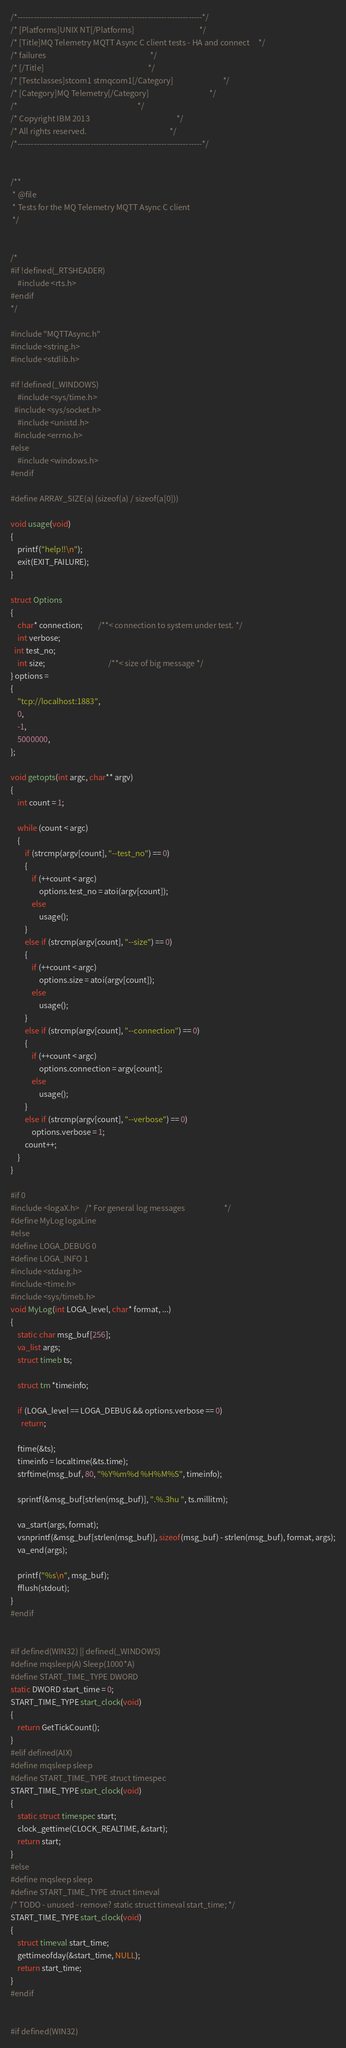Convert code to text. <code><loc_0><loc_0><loc_500><loc_500><_C_>/*--------------------------------------------------------------------*/
/* [Platforms]UNIX NT[/Platforms]                                     */
/* [Title]MQ Telemetry MQTT Async C client tests - HA and connect     */
/* failures                                                           */
/* [/Title]                                                           */
/* [Testclasses]stcom1 stmqcom1[/Category]                            */
/* [Category]MQ Telemetry[/Category]                                  */
/*                                                                    */
/* Copyright IBM 2013                                                 */
/* All rights reserved.                                               */
/*--------------------------------------------------------------------*/


/**
 * @file
 * Tests for the MQ Telemetry MQTT Async C client
 */


/*
#if !defined(_RTSHEADER)
	#include <rts.h>
#endif
*/

#include "MQTTAsync.h"
#include <string.h>
#include <stdlib.h>

#if !defined(_WINDOWS)
	#include <sys/time.h>
  #include <sys/socket.h>
	#include <unistd.h>
  #include <errno.h>
#else
	#include <windows.h>
#endif

#define ARRAY_SIZE(a) (sizeof(a) / sizeof(a[0]))

void usage(void)
{
	printf("help!!\n");
	exit(EXIT_FAILURE);
}

struct Options
{
	char* connection;         /**< connection to system under test. */
	int verbose;
  int test_no;
	int size;									/**< size of big message */
} options =
{
	"tcp://localhost:1883",
	0,
	-1,
	5000000,
};

void getopts(int argc, char** argv)
{
	int count = 1;

	while (count < argc)
	{
		if (strcmp(argv[count], "--test_no") == 0)
		{
			if (++count < argc)
				options.test_no = atoi(argv[count]);
			else
				usage();
		}
		else if (strcmp(argv[count], "--size") == 0)
		{
			if (++count < argc)
				options.size = atoi(argv[count]);
			else
				usage();
		}
		else if (strcmp(argv[count], "--connection") == 0)
		{
			if (++count < argc)
				options.connection = argv[count];
			else
				usage();
		}
		else if (strcmp(argv[count], "--verbose") == 0)
			options.verbose = 1;
		count++;
	}
}

#if 0
#include <logaX.h>   /* For general log messages                      */
#define MyLog logaLine
#else
#define LOGA_DEBUG 0
#define LOGA_INFO 1
#include <stdarg.h>
#include <time.h>
#include <sys/timeb.h>
void MyLog(int LOGA_level, char* format, ...)
{
	static char msg_buf[256];
	va_list args;
	struct timeb ts;

	struct tm *timeinfo;

	if (LOGA_level == LOGA_DEBUG && options.verbose == 0)
	  return;

	ftime(&ts);
	timeinfo = localtime(&ts.time);
	strftime(msg_buf, 80, "%Y%m%d %H%M%S", timeinfo);

	sprintf(&msg_buf[strlen(msg_buf)], ".%.3hu ", ts.millitm);

	va_start(args, format);
	vsnprintf(&msg_buf[strlen(msg_buf)], sizeof(msg_buf) - strlen(msg_buf), format, args);
	va_end(args);

	printf("%s\n", msg_buf);
	fflush(stdout);
}
#endif


#if defined(WIN32) || defined(_WINDOWS)
#define mqsleep(A) Sleep(1000*A)
#define START_TIME_TYPE DWORD
static DWORD start_time = 0;
START_TIME_TYPE start_clock(void)
{
	return GetTickCount();
}
#elif defined(AIX)
#define mqsleep sleep
#define START_TIME_TYPE struct timespec
START_TIME_TYPE start_clock(void)
{
	static struct timespec start;
	clock_gettime(CLOCK_REALTIME, &start);
	return start;
}
#else
#define mqsleep sleep
#define START_TIME_TYPE struct timeval
/* TODO - unused - remove? static struct timeval start_time; */
START_TIME_TYPE start_clock(void)
{
	struct timeval start_time;
	gettimeofday(&start_time, NULL);
	return start_time;
}
#endif


#if defined(WIN32)</code> 